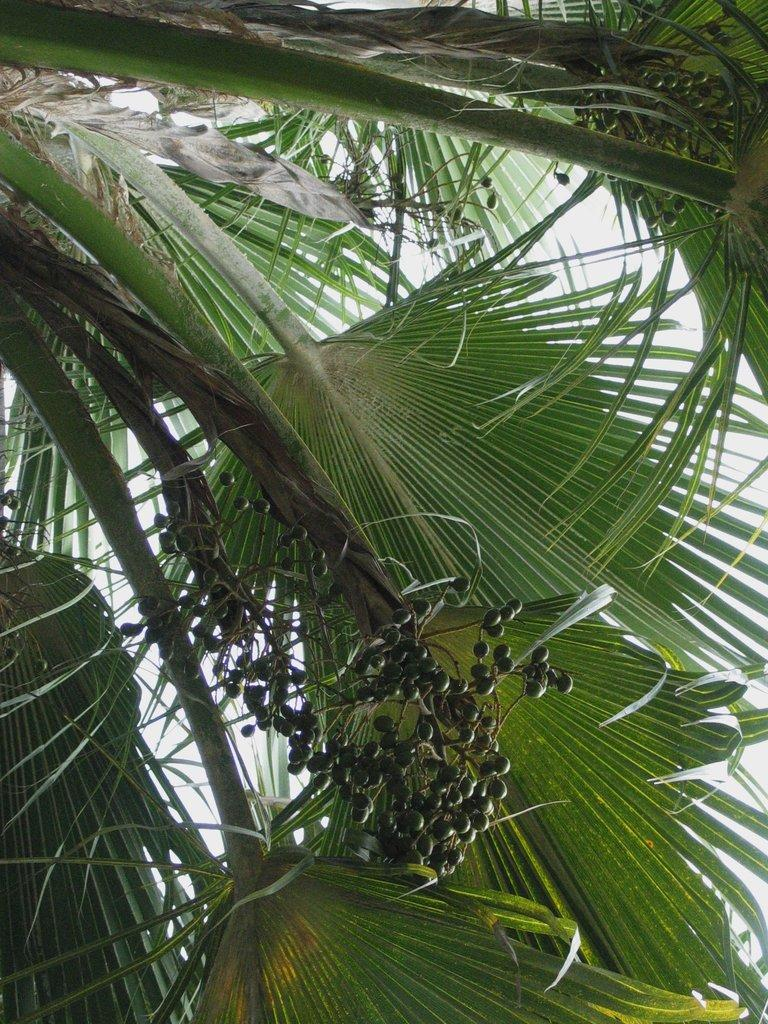What is present in the picture? There is a tree in the picture. Can you describe the tree's leaves? The tree has large leaves. Are there any fruits on the tree? Yes, the tree has small fruits. What type of word can be seen carved into the tree trunk in the image? There is no word carved into the tree trunk in the image; it only shows a tree with large leaves and small fruits. 